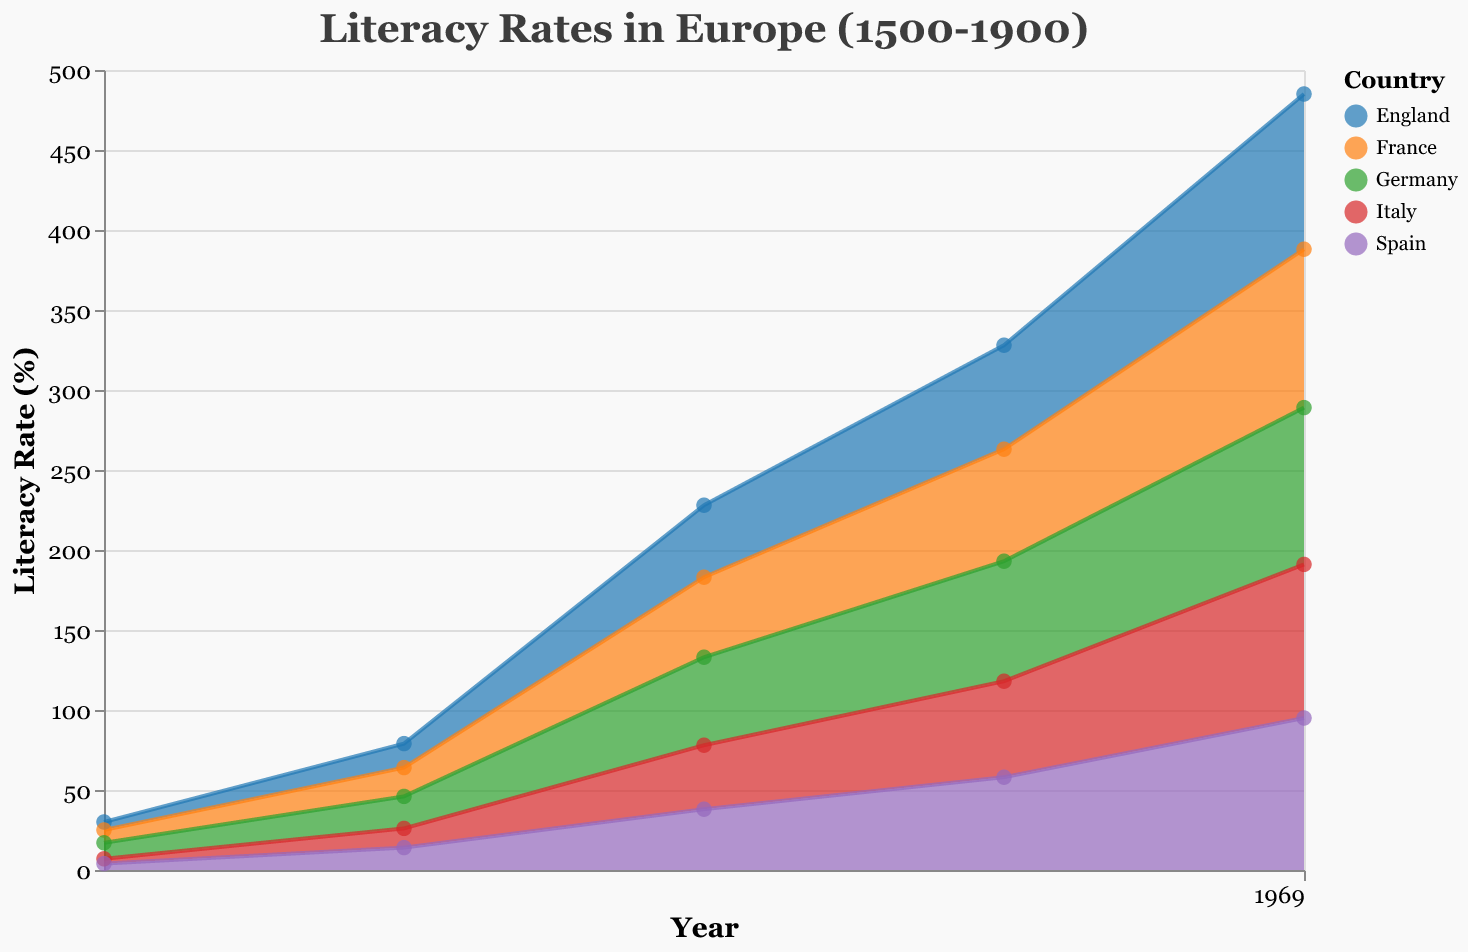What is the title of the area chart? The title can be found at the top of the chart, indicating what the chart represents.
Answer: Literacy Rates in Europe (1500-1900) Which country had the highest literacy rate in the year 1500? By observing the y-axis values for the year 1500, we can see which country had the highest point.
Answer: Germany How did the literacy rate in England change from 1500 to 1600? Look at the difference in the literacy rate for England between 1500 and 1600.
Answer: Increased by 10% Which country shows the most significant increase in literacy rate between 1500 and 1900? Compare the differences in literacy rates for each country from 1500 to 1900.
Answer: France What is the literacy rate of Italy in 1700? Check the y-axis value for Italy in the year 1700.
Answer: 40% Compare the literacy rates between France and Germany in the year 1700. Which country had a higher literacy rate? Look at the literacy rates for both France and Germany in the year 1700 and compare them.
Answer: Germany By how much did the literacy rate in Spain increase between 1800 and 1900? Calculate the difference in Spain's literacy rates in the year 1800 and 1900.
Answer: 37% Which country had the lowest literacy rate in 1900? Identify the lowest y-axis value in the year 1900 across all countries.
Answer: Spain What general trend can be observed in the literacy rates of Europe from 1500 to 1900? Observe how the literacy rates change over time across all countries.
Answer: Increasing trend Estimate the average literacy rate across all countries in the year 1600. Add the literacy rates for all countries in 1600 and divide by the number of countries. The sum is (15 + 18 + 20 + 12 + 14) = 79, and there are 5 countries, so the average is 79/5 = 15.8
Answer: 15.8% 